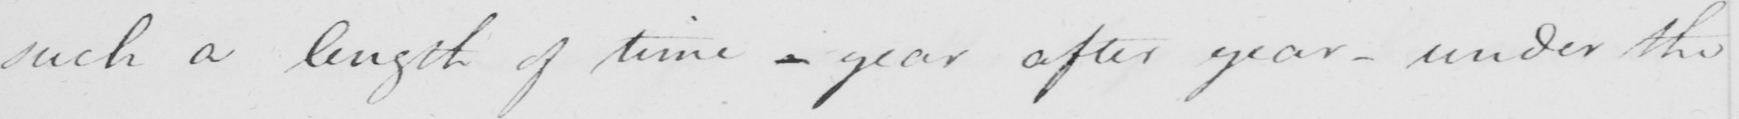What text is written in this handwritten line? such a length of time  _  year after year  _  under the 